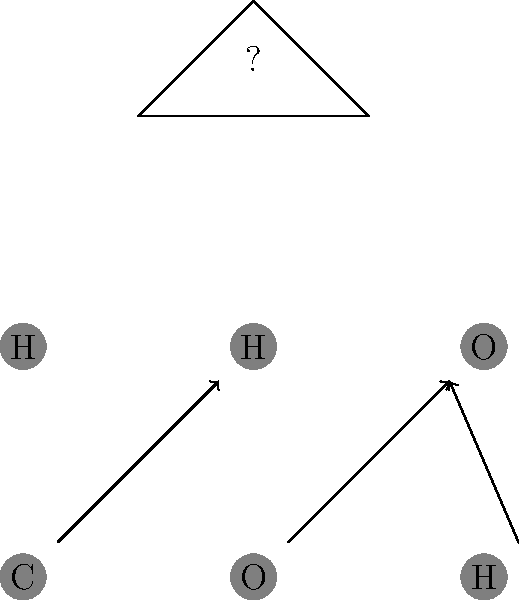Arrange the given molecular structures to form methanol (CH₃OH). Which molecule should replace the question mark in the final structure? To solve this puzzle, let's follow these steps:

1. Identify the given molecules:
   - Carbon (C)
   - Oxygen (O)
   - Hydrogen (H) (three times)

2. Recall the structure of methanol (CH₃OH):
   - It consists of one carbon atom bonded to three hydrogen atoms and one hydroxyl group (OH).

3. Arrange the molecules:
   - The carbon (C) should be at the center.
   - Three hydrogen (H) atoms should be bonded to the carbon.
   - The oxygen (O) should be bonded to the carbon.
   - The remaining hydrogen (H) should be bonded to the oxygen to form the hydroxyl group (OH).

4. Analyze the final structure in the diagram:
   - The triangle represents the basic structure of methanol.
   - Two corners are already filled with C and O.
   - The question mark represents the molecule that should be at the top of the triangle.

5. Determine the missing molecule:
   - Since we need three hydrogen atoms bonded to the carbon, and we already have two H atoms in the given molecules, the missing molecule at the top of the triangle must be hydrogen (H).

Therefore, the molecule that should replace the question mark in the final structure is hydrogen (H).
Answer: H 